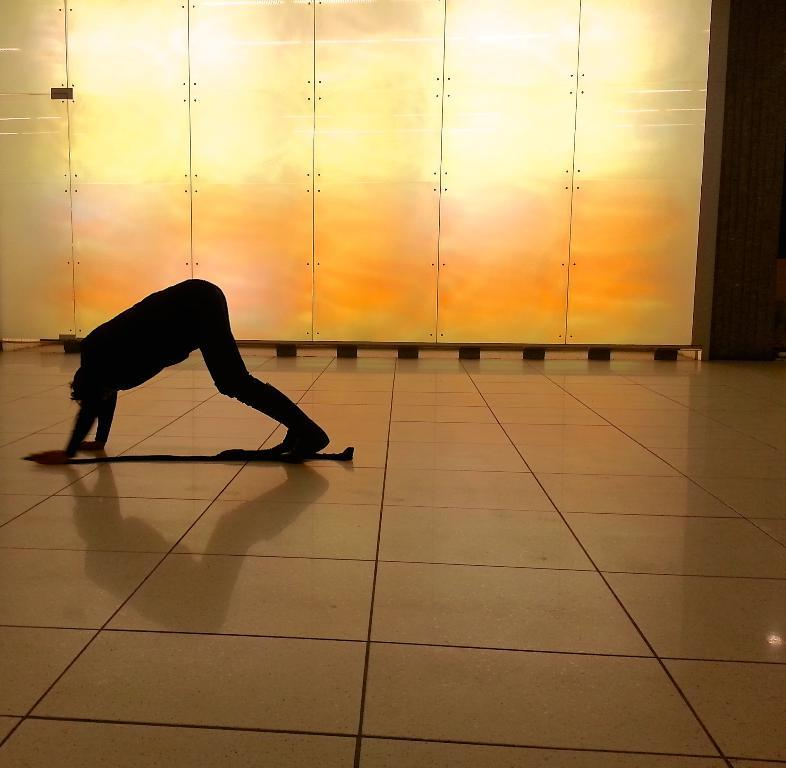What type of view is shown in the image? The image is an inside view. What is the person on the floor doing? The person appears to be doing some exercise. What can be seen in the background of the image? There is a wall in the background of the image. What request does the queen make in the image? There is no queen or request present in the image. 